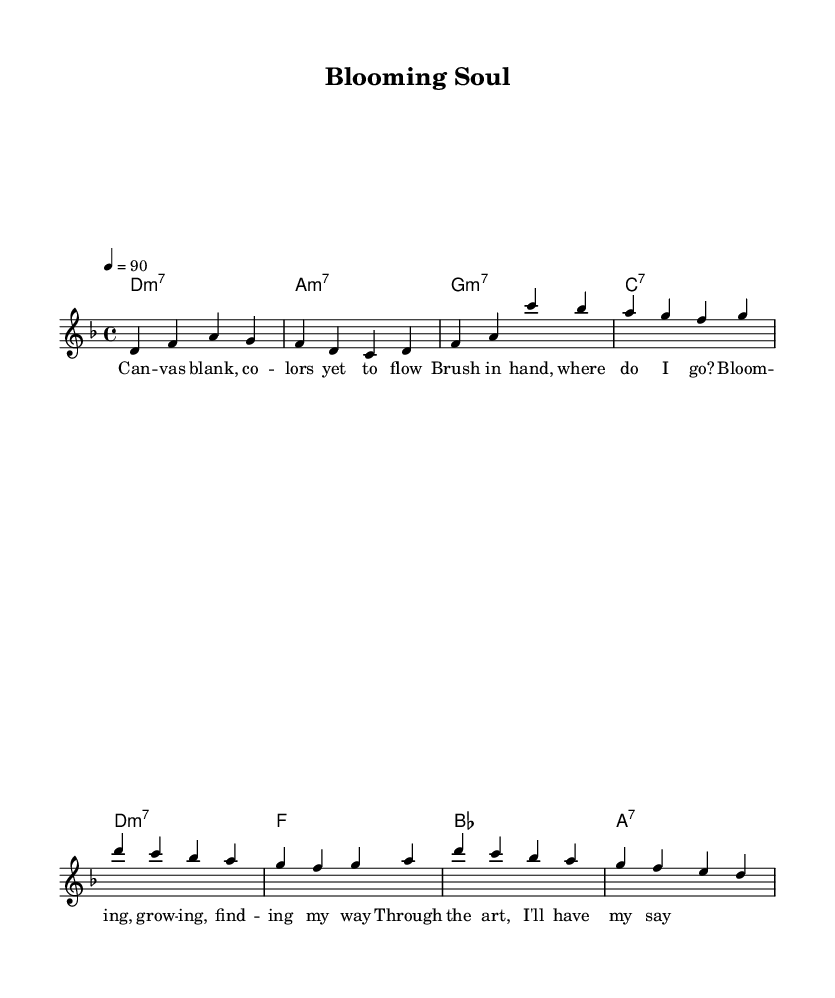What is the key signature of this music? The key signature is indicated before the time signature and shows that there is one flat. This corresponds to D minor, which has one flat (C).
Answer: D minor What is the time signature of this piece? The time signature is placed after the key signature and indicates how many beats are in each measure. It shows a 4 on the top and a 4 on the bottom, meaning there are four beats in each measure and that the quarter note gets one beat.
Answer: 4/4 What is the tempo marking for this piece? The tempo is indicated at the beginning of the music, specifying a speed of 90 beats per minute, which tells performers how fast to play the piece.
Answer: 90 How many measures are in the verse section? By counting the measures in the melody section, there are four measures that comprise the verse. Each measure includes a set of notes separated by vertical lines, which represent the end of a measure.
Answer: 4 What type of chord follows the first measure of the verse? The chord names are listed below the melody, and the first chord in the verse is written as "d:m7", indicating a D minor 7 chord.
Answer: d:m7 What theme does the chorus explore? The lyrics of the chorus, specifically words like "Blooming," "growing," and "finding my way," suggest themes of personal development and self-discovery, fitting for neo-soul music.
Answer: Self-discovery What type of style does this piece represent? The overall composition structure, lyrical themes, and chord progressions are characteristic of neo-soul, which often blends elements of traditional soul with contemporary R&B and jazz influences.
Answer: Neo-soul 